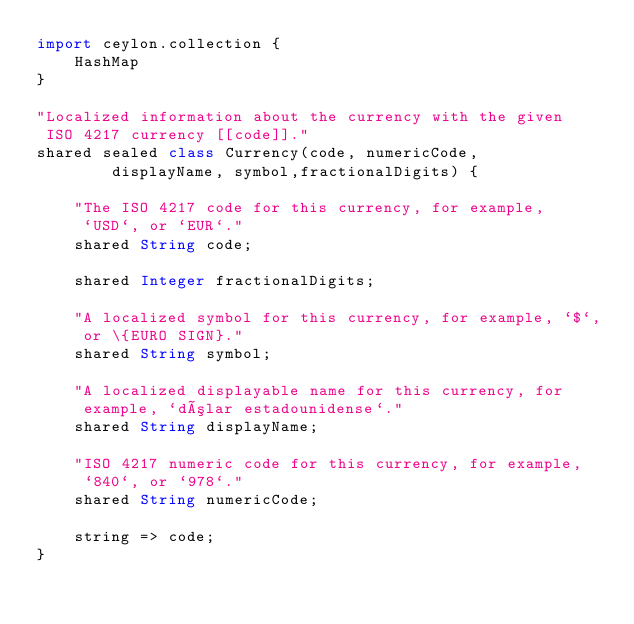Convert code to text. <code><loc_0><loc_0><loc_500><loc_500><_Ceylon_>import ceylon.collection {
    HashMap
}

"Localized information about the currency with the given 
 ISO 4217 currency [[code]]."
shared sealed class Currency(code, numericCode, 
        displayName, symbol,fractionalDigits) {
    
    "The ISO 4217 code for this currency, for example,
     `USD`, or `EUR`."
    shared String code;
    
    shared Integer fractionalDigits;
    
    "A localized symbol for this currency, for example, `$`,
     or \{EURO SIGN}."
    shared String symbol;
    
    "A localized displayable name for this currency, for 
     example, `dólar estadounidense`."
    shared String displayName;
    
    "ISO 4217 numeric code for this currency, for example,
     `840`, or `978`."
    shared String numericCode;
    
    string => code;
}
</code> 